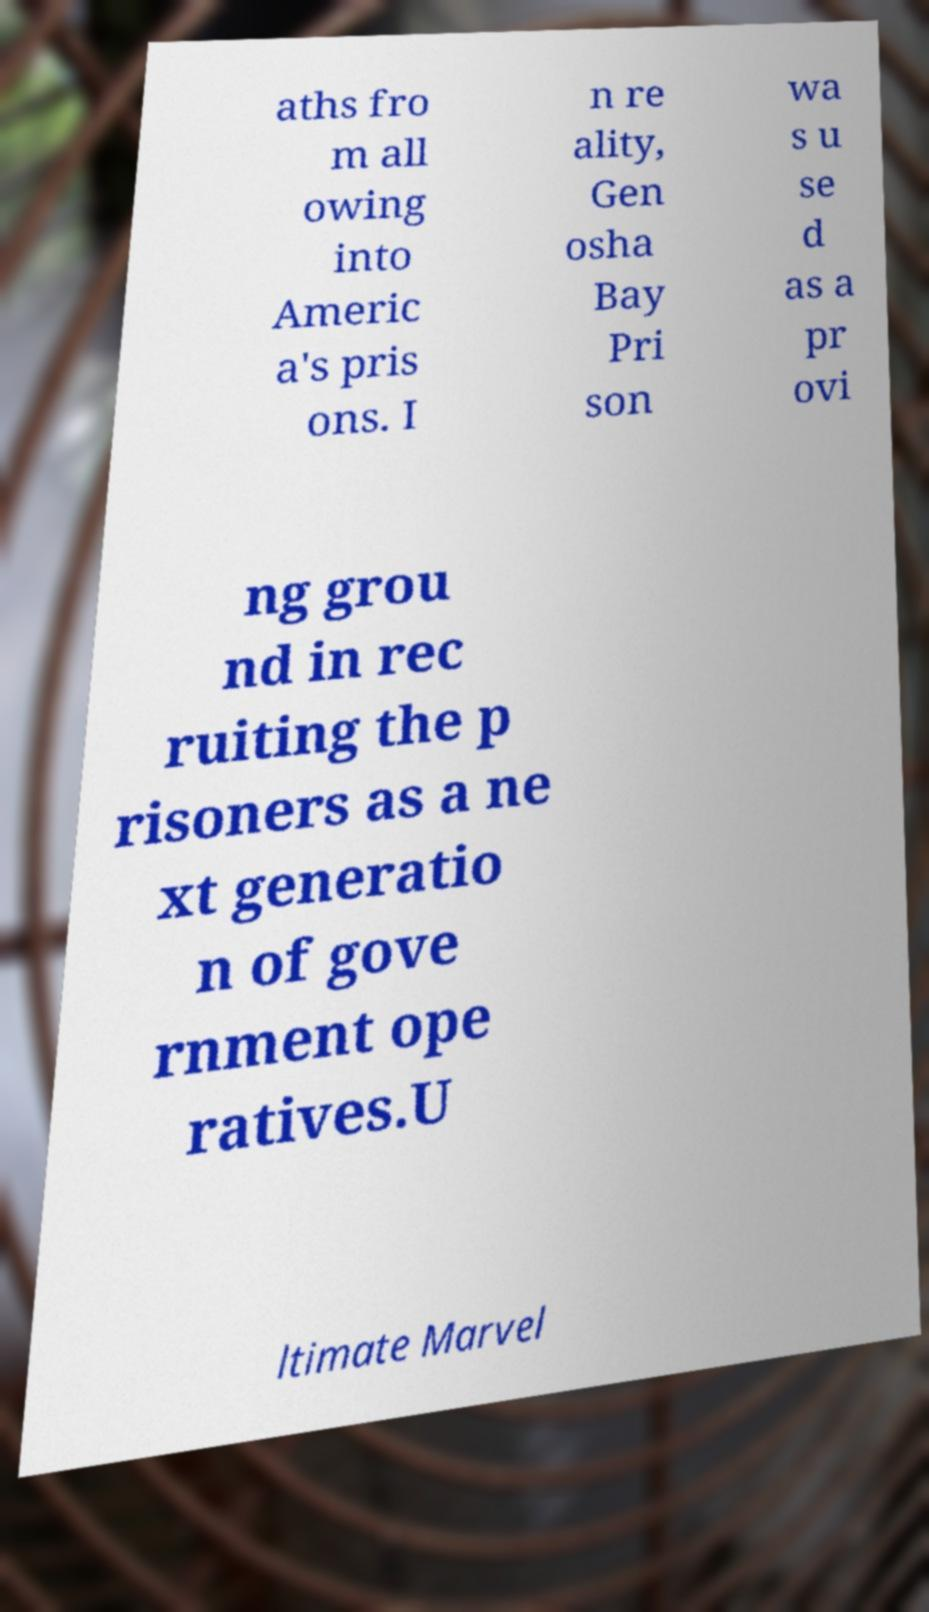What messages or text are displayed in this image? I need them in a readable, typed format. aths fro m all owing into Americ a's pris ons. I n re ality, Gen osha Bay Pri son wa s u se d as a pr ovi ng grou nd in rec ruiting the p risoners as a ne xt generatio n of gove rnment ope ratives.U ltimate Marvel 